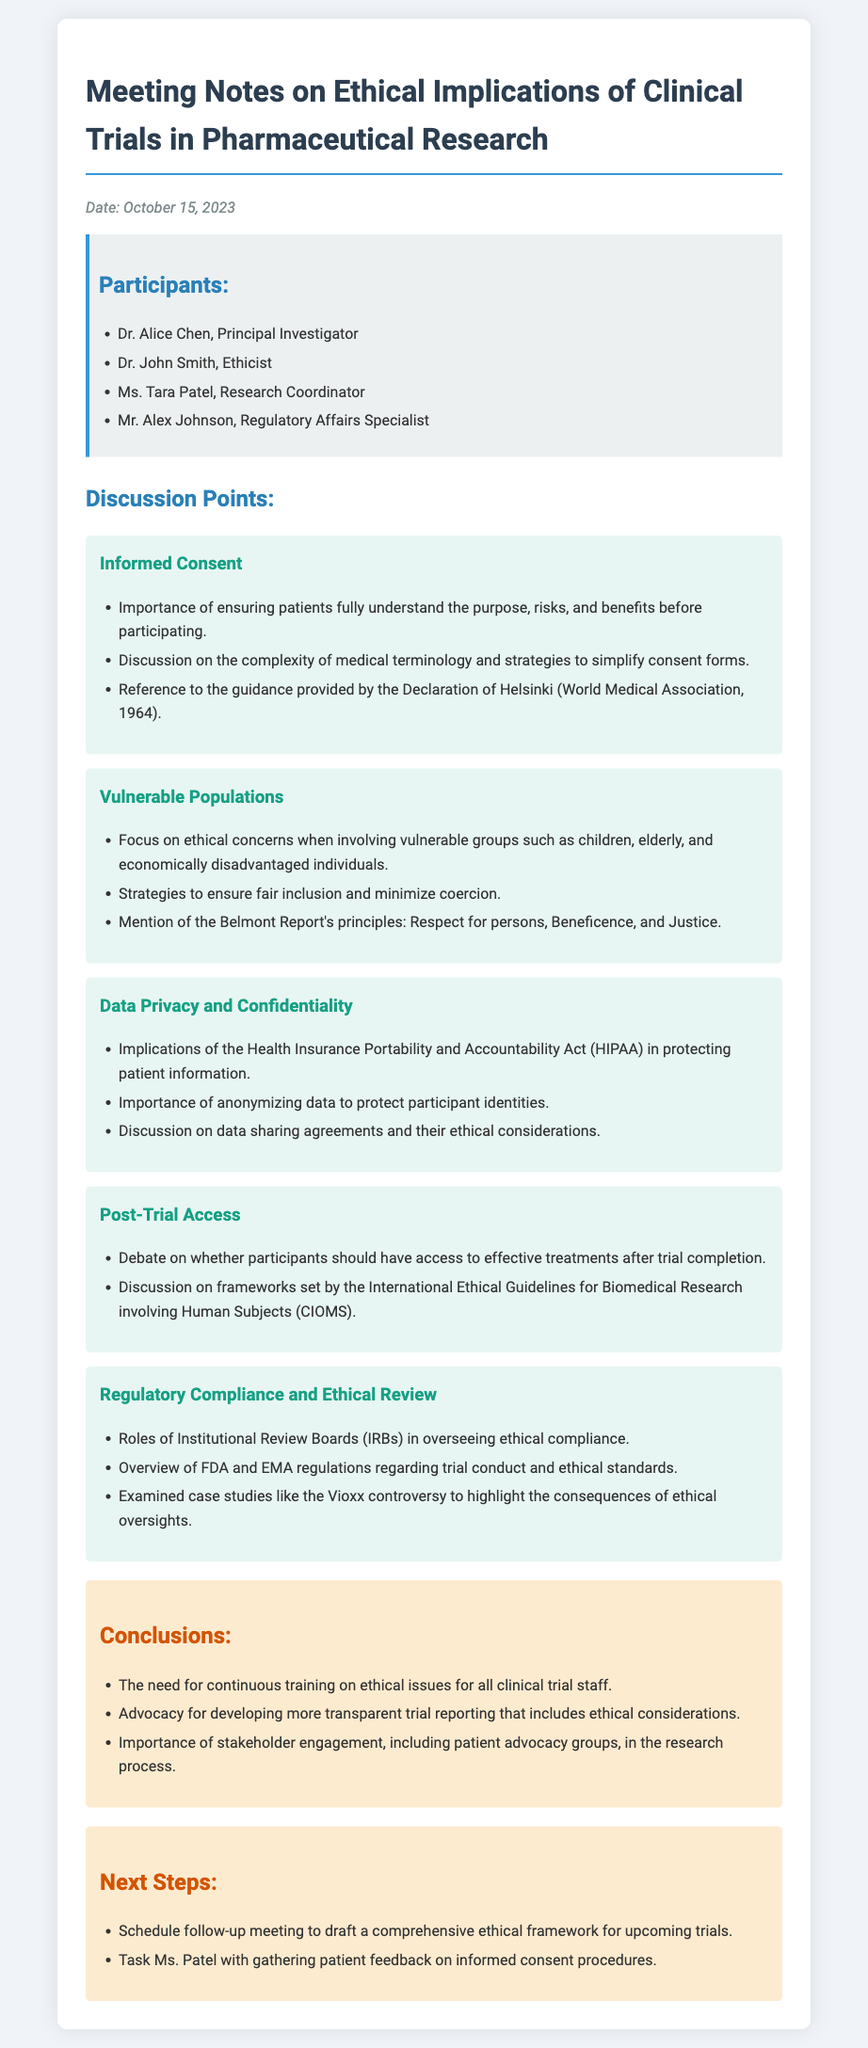What is the date of the meeting? The date of the meeting is mentioned at the top of the document.
Answer: October 15, 2023 Who is the Principal Investigator? The document lists the participants and their roles, including the Principal Investigator.
Answer: Dr. Alice Chen What ethical guideline is referenced for informed consent? The discussion point on informed consent mentions a specific guideline related to ethical practices.
Answer: Declaration of Helsinki Which groups are mentioned as vulnerable populations? The document lists specific demographic groups that raise ethical concerns.
Answer: Children, elderly, and economically disadvantaged individuals What is one key principle from the Belmont Report? The document mentions principles from the Belmont Report in the context of vulnerable populations.
Answer: Justice What act is referenced regarding data privacy? The discussion on data privacy includes a reference to a specific piece of legislation.
Answer: HIPAA What is one of the conclusions drawn from the meeting? The conclusions section summarizes key takeaways, highlighting important needs moving forward.
Answer: Continuous training on ethical issues What is the next step regarding patient feedback? The next steps section outlines specific tasks to be completed after the meeting.
Answer: Gather patient feedback on informed consent procedures Which regulatory bodies are mentioned in the document? The discussion on regulatory compliance includes references to organizations overseeing clinical trials.
Answer: FDA and EMA 